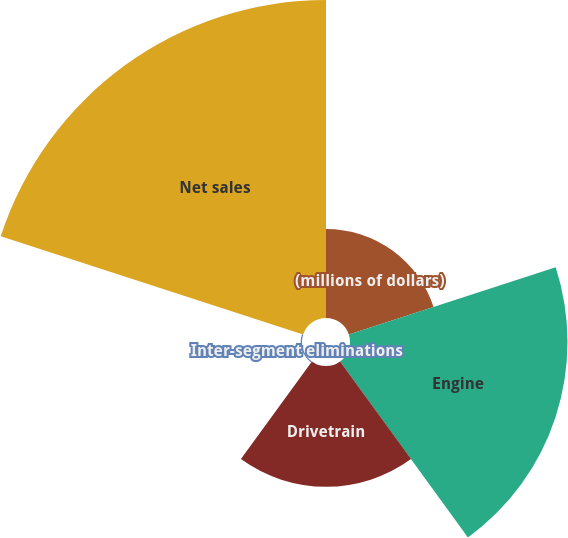Convert chart to OTSL. <chart><loc_0><loc_0><loc_500><loc_500><pie_chart><fcel>(millions of dollars)<fcel>Engine<fcel>Drivetrain<fcel>Inter-segment eliminations<fcel>Net sales<nl><fcel>11.93%<fcel>29.13%<fcel>16.17%<fcel>0.17%<fcel>42.59%<nl></chart> 